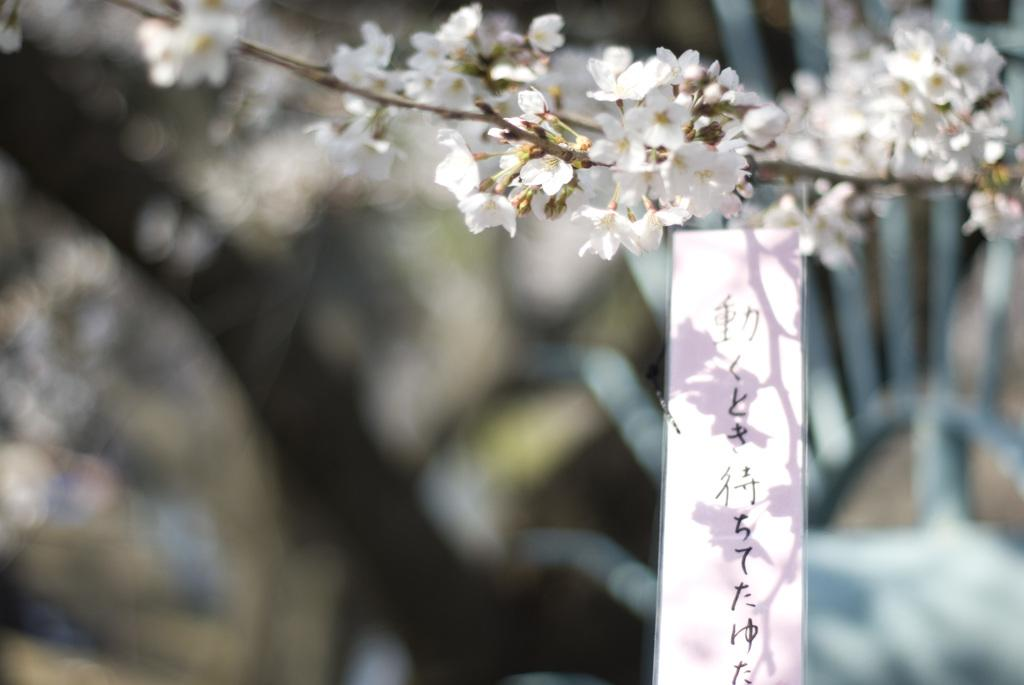What type of flora is visible at the top of the image? There are flowers at the top side of the image. What can be found on the right side of the image? There is a label on the right side of the image. What type of board is being worn by the flowers in the image? There is no board present in the image, as it features flowers and a label. What color is the skirt of the label in the image? There is no skirt present in the image, as it features flowers and a label. 